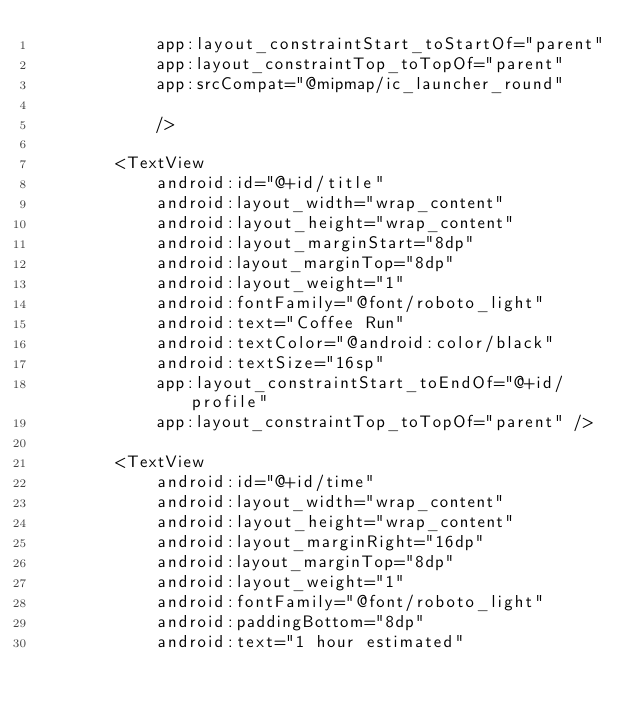<code> <loc_0><loc_0><loc_500><loc_500><_XML_>            app:layout_constraintStart_toStartOf="parent"
            app:layout_constraintTop_toTopOf="parent"
            app:srcCompat="@mipmap/ic_launcher_round"

            />

        <TextView
            android:id="@+id/title"
            android:layout_width="wrap_content"
            android:layout_height="wrap_content"
            android:layout_marginStart="8dp"
            android:layout_marginTop="8dp"
            android:layout_weight="1"
            android:fontFamily="@font/roboto_light"
            android:text="Coffee Run"
            android:textColor="@android:color/black"
            android:textSize="16sp"
            app:layout_constraintStart_toEndOf="@+id/profile"
            app:layout_constraintTop_toTopOf="parent" />

        <TextView
            android:id="@+id/time"
            android:layout_width="wrap_content"
            android:layout_height="wrap_content"
            android:layout_marginRight="16dp"
            android:layout_marginTop="8dp"
            android:layout_weight="1"
            android:fontFamily="@font/roboto_light"
            android:paddingBottom="8dp"
            android:text="1 hour estimated"</code> 